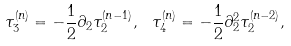<formula> <loc_0><loc_0><loc_500><loc_500>\tau _ { 3 } ^ { ( n ) } = - \frac { 1 } { 2 } \partial _ { 2 } \tau _ { 2 } ^ { ( n - 1 ) } , \ \tau _ { 4 } ^ { ( n ) } = - \frac { 1 } { 2 } \partial ^ { 2 } _ { 2 } \tau _ { 2 } ^ { ( n - 2 ) } ,</formula> 